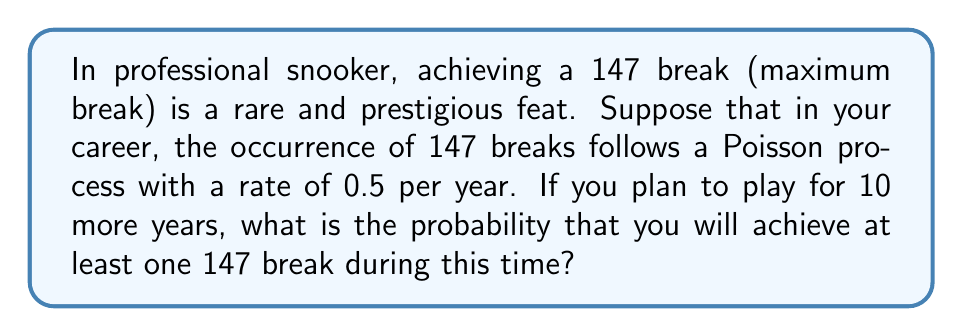What is the answer to this math problem? Let's approach this step-by-step using the properties of a Poisson process:

1) In a Poisson process, the number of events in a fixed interval follows a Poisson distribution.

2) Let $X$ be the number of 147 breaks in 10 years. Then $X \sim \text{Poisson}(\lambda)$, where $\lambda$ is the expected number of events in 10 years.

3) Calculate $\lambda$:
   $\lambda = \text{rate} \times \text{time} = 0.5 \text{ per year} \times 10 \text{ years} = 5$

4) We want to find $P(X \geq 1)$, which is equivalent to $1 - P(X = 0)$

5) For a Poisson distribution:
   $P(X = k) = \frac{e^{-\lambda}\lambda^k}{k!}$

6) Therefore:
   $P(X = 0) = \frac{e^{-5}5^0}{0!} = e^{-5}$

7) Thus:
   $P(X \geq 1) = 1 - P(X = 0) = 1 - e^{-5}$

8) Calculate the final result:
   $1 - e^{-5} \approx 0.9933$
Answer: $1 - e^{-5} \approx 0.9933$ 